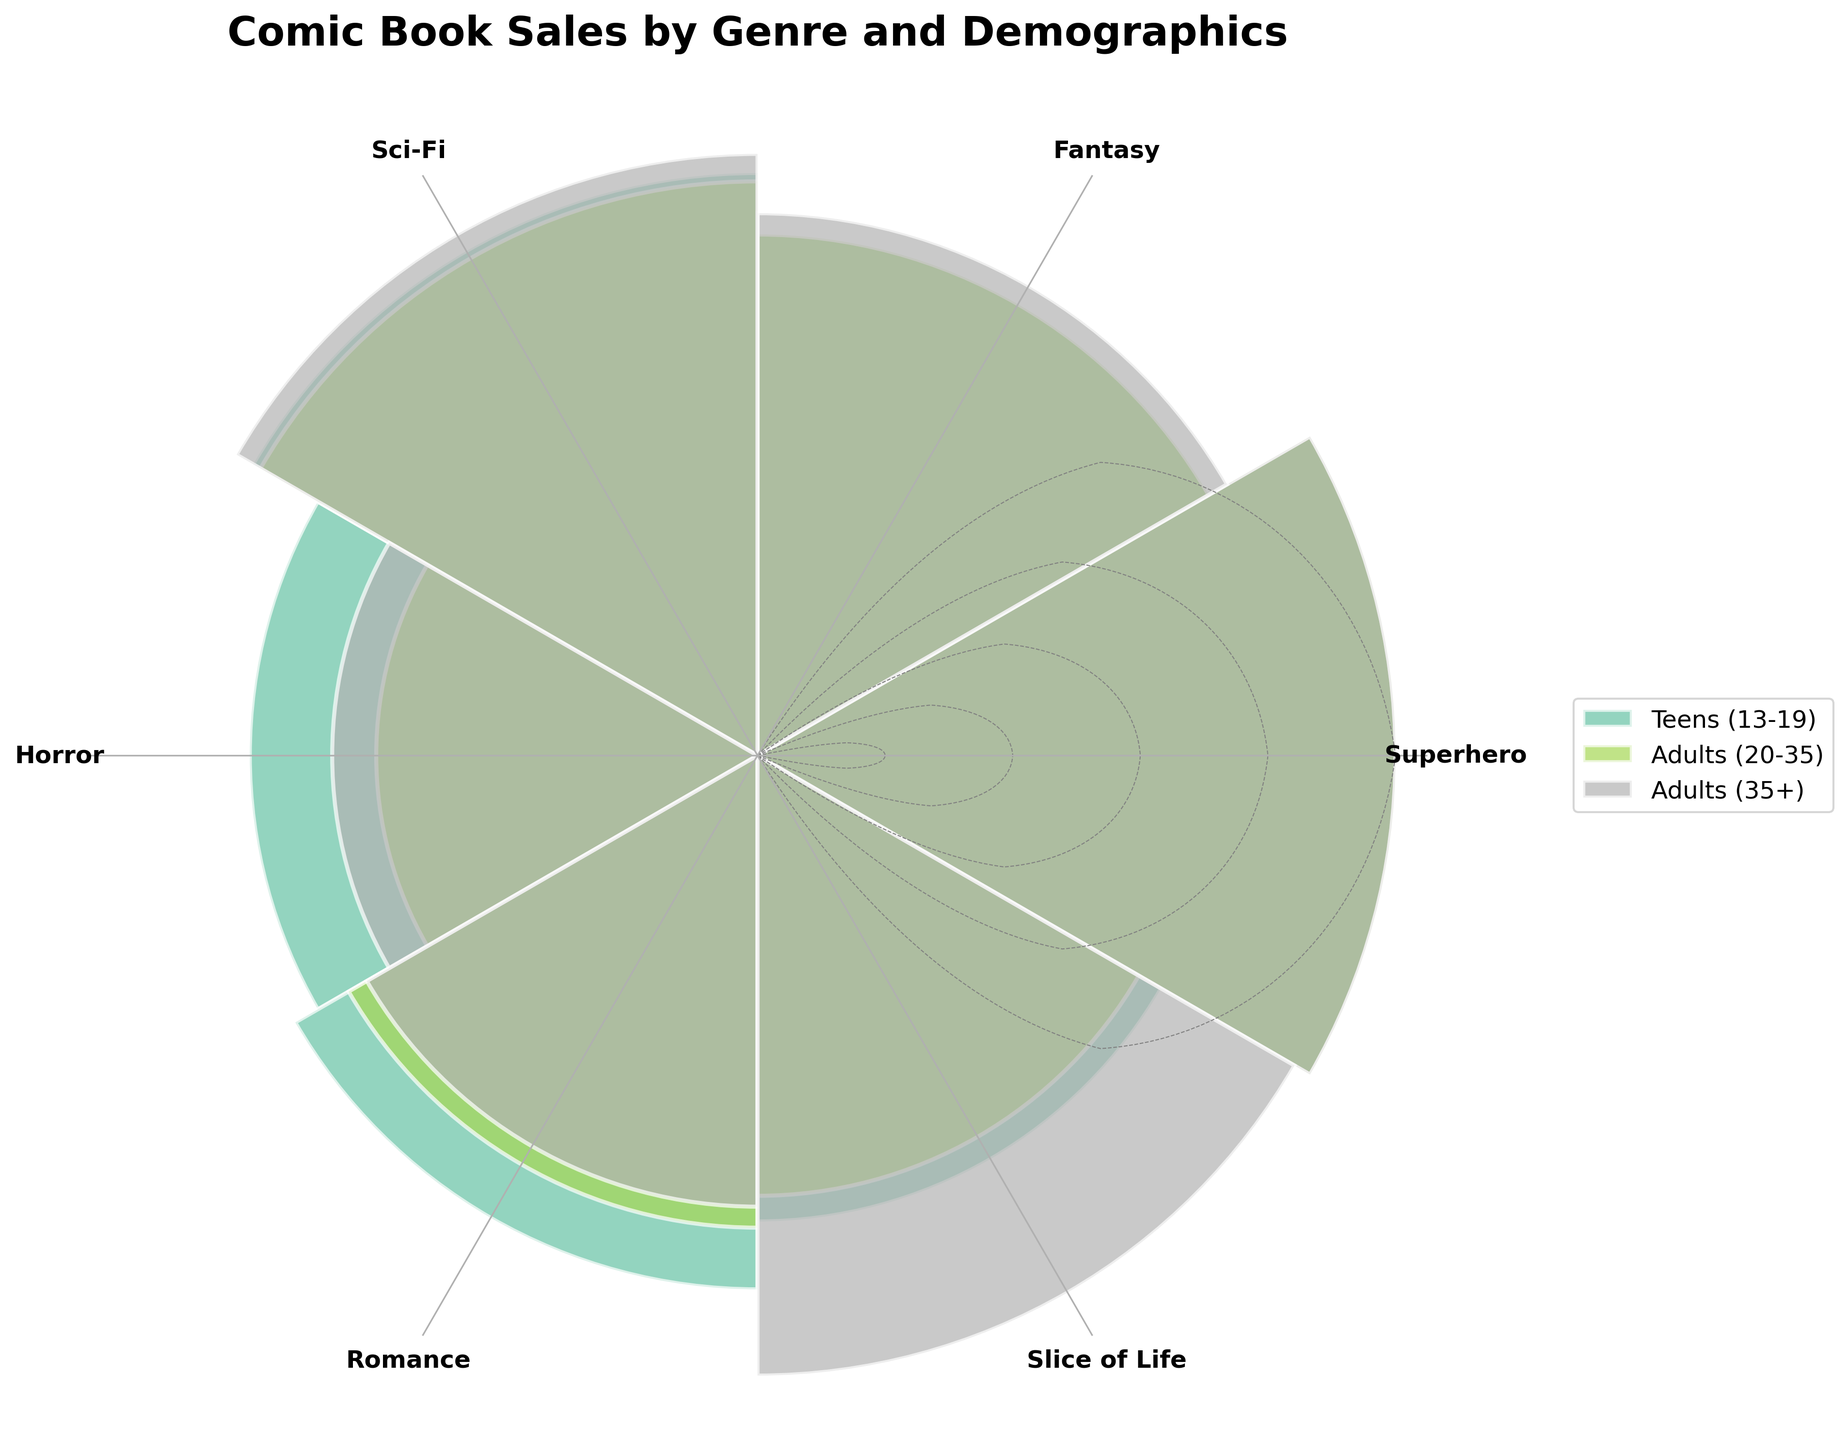What's the title of the chart? The title of the chart is located at the top and typically provides a summary of the chart's content. In this case, the title is 'Comic Book Sales by Genre and Demographics'.
Answer: Comic Book Sales by Genre and Demographics How many different genres are displayed in the chart? The number of genres can be found by counting the unique genre labels around the polar plot. According to the provided data, there are six genres.
Answer: Six Which demographic group has the highest sales units for the Superhero genre? To find the highest sales units for the Superhero genre, look at the length of the bars for each demographic group within the Superhero section. The longest bar represents the sales units. The 'Adults (20-35)' group has the longest bar for the Superhero genre.
Answer: Adults (20-35) What are the genres with the smallest sales units for 'Adults (35+)'? To identify the correct genres, lookup the shortest bars for the 'Adults (35+)' demographic. The shortest bars appear in the Horror and Romance genres.
Answer: Horror and Romance What's the total sales for the Fantasy genre across all demographics? Add the sales units for each demographic within the Fantasy genre: Teens (13-19) with 200,000, Adults (20-35) with 280,000, and Adults (35+) with 130,000. The total is 200000 + 280000 + 130000 = 610000.
Answer: 610,000 Which genre has the widest distribution of sales units across different demographics? To answer this, look for the genre with the most varying bar lengths. The Superhero genre shows the widest range as 'Adults (20-35)' has the highest sales while 'Adults (35+)' has significantly fewer sales.
Answer: Superhero By how much do sales units of Romance for Teens (13-19) exceed those for Slice of Life for the same demographic? Subtract the Slice of Life sales units for Teens from the Romance sales units for Teens: 210000 - 160000 = 50000.
Answer: 50,000 Is the average sales for Sci-Fi higher than the average sales for Romance? Calculate the total and average sales for each genre. Sci-Fi total sales: 250000 + 340000 + 160000 = 750000; average = 750000/3 = 250000. Romance total sales: 210000 + 230000 + 90000 = 530000; average = 530000/3 = 176666.67. Since 250000 > 176666.67, Sci-Fi has a higher average.
Answer: Yes What is the genre with the lowest cumulative sales for Adults (20-35)? Identify the genre with the smallest bar length for the Adults (20-35) demographic. The Horror genre shows the lowest sales which contribute to the lowest cumulative sales.
Answer: Horror 